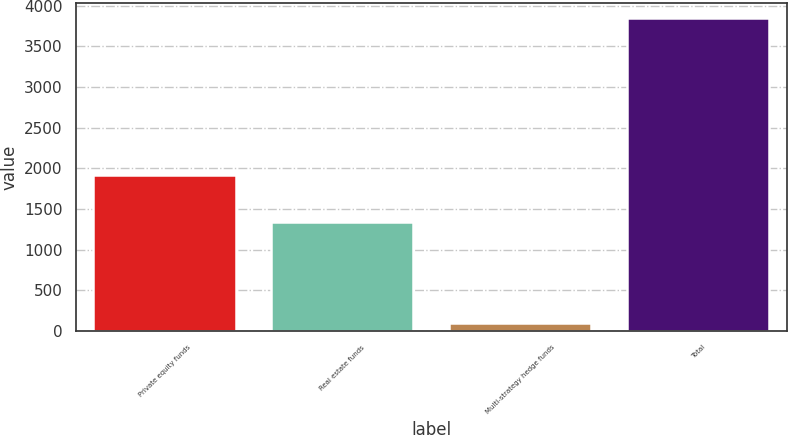Convert chart. <chart><loc_0><loc_0><loc_500><loc_500><bar_chart><fcel>Private equity funds<fcel>Real estate funds<fcel>Multi-strategy hedge funds<fcel>Total<nl><fcel>1917<fcel>1337<fcel>94<fcel>3843<nl></chart> 